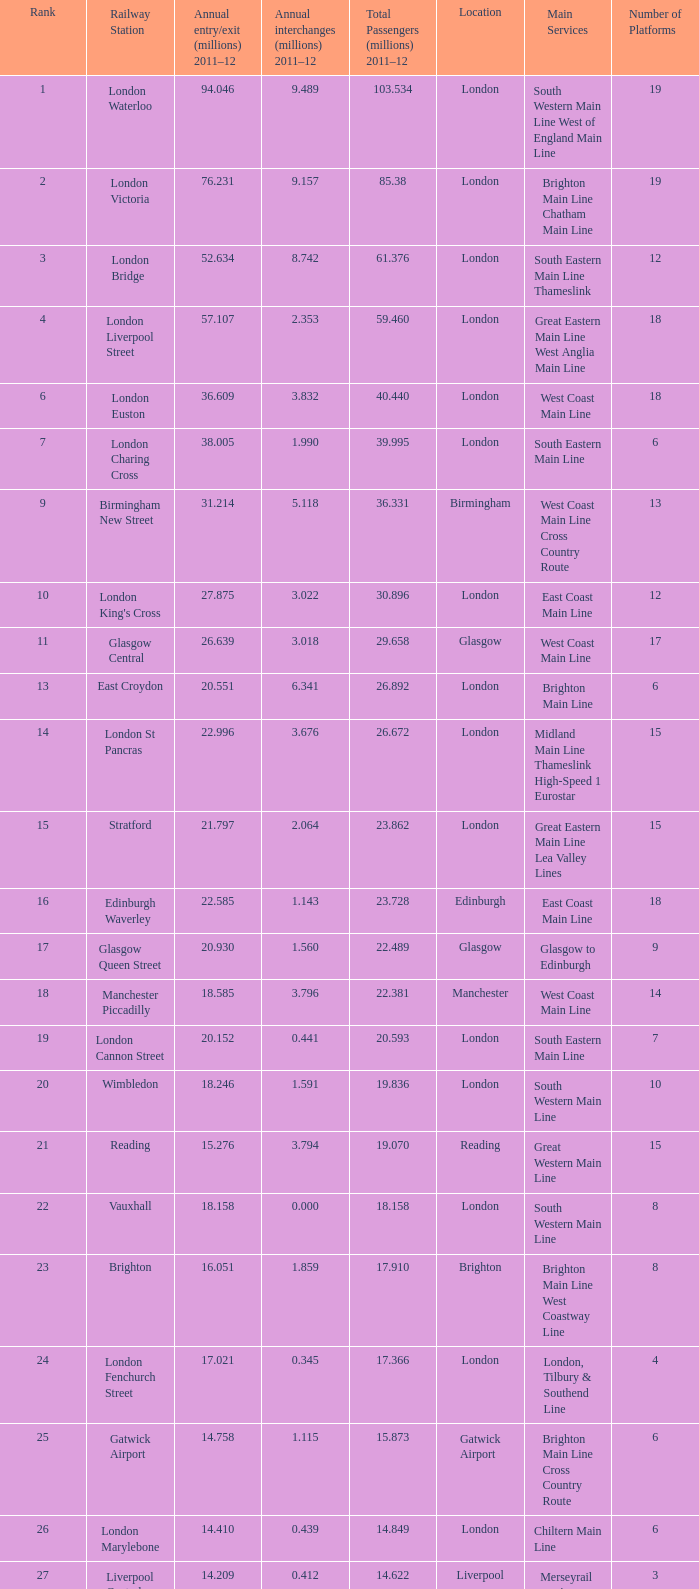Which area recorded 10 London. 